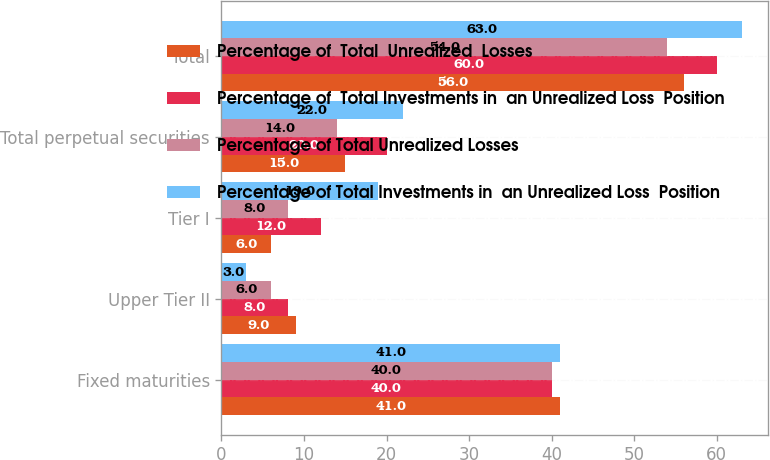Convert chart. <chart><loc_0><loc_0><loc_500><loc_500><stacked_bar_chart><ecel><fcel>Fixed maturities<fcel>Upper Tier II<fcel>Tier I<fcel>Total perpetual securities<fcel>Total<nl><fcel>Percentage of  Total  Unrealized  Losses<fcel>41<fcel>9<fcel>6<fcel>15<fcel>56<nl><fcel>Percentage of  Total Investments in  an Unrealized Loss  Position<fcel>40<fcel>8<fcel>12<fcel>20<fcel>60<nl><fcel>Percentage of Total Unrealized Losses<fcel>40<fcel>6<fcel>8<fcel>14<fcel>54<nl><fcel>Percentage of Total Investments in  an Unrealized Loss  Position<fcel>41<fcel>3<fcel>19<fcel>22<fcel>63<nl></chart> 